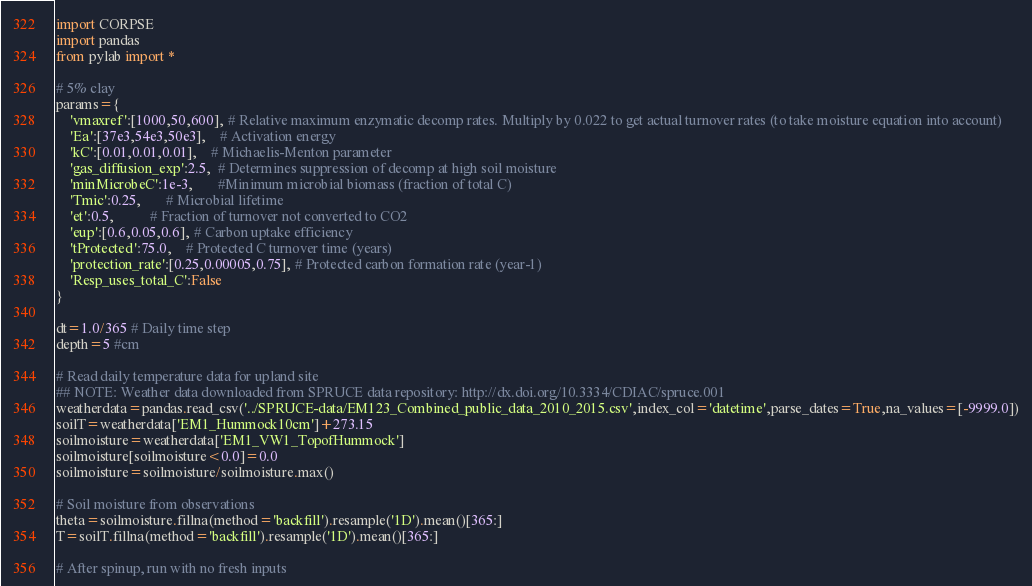Convert code to text. <code><loc_0><loc_0><loc_500><loc_500><_Python_>import CORPSE
import pandas
from pylab import *

# 5% clay
params={
    'vmaxref':[1000,50,600], # Relative maximum enzymatic decomp rates. Multiply by 0.022 to get actual turnover rates (to take moisture equation into account)
    'Ea':[37e3,54e3,50e3],    # Activation energy
    'kC':[0.01,0.01,0.01],    # Michaelis-Menton parameter
    'gas_diffusion_exp':2.5,  # Determines suppression of decomp at high soil moisture
    'minMicrobeC':1e-3,       #Minimum microbial biomass (fraction of total C)
    'Tmic':0.25,       # Microbial lifetime
    'et':0.5,          # Fraction of turnover not converted to CO2
    'eup':[0.6,0.05,0.6], # Carbon uptake efficiency
    'tProtected':75.0,    # Protected C turnover time (years)
    'protection_rate':[0.25,0.00005,0.75], # Protected carbon formation rate (year-1)
    'Resp_uses_total_C':False
}

dt=1.0/365 # Daily time step
depth=5 #cm

# Read daily temperature data for upland site
## NOTE: Weather data downloaded from SPRUCE data repository: http://dx.doi.org/10.3334/CDIAC/spruce.001
weatherdata=pandas.read_csv('../SPRUCE-data/EM123_Combined_public_data_2010_2015.csv',index_col='datetime',parse_dates=True,na_values=[-9999.0])
soilT=weatherdata['EM1_Hummock10cm']+273.15
soilmoisture=weatherdata['EM1_VW1_TopofHummock']
soilmoisture[soilmoisture<0.0]=0.0
soilmoisture=soilmoisture/soilmoisture.max()

# Soil moisture from observations
theta=soilmoisture.fillna(method='backfill').resample('1D').mean()[365:]
T=soilT.fillna(method='backfill').resample('1D').mean()[365:]

# After spinup, run with no fresh inputs</code> 